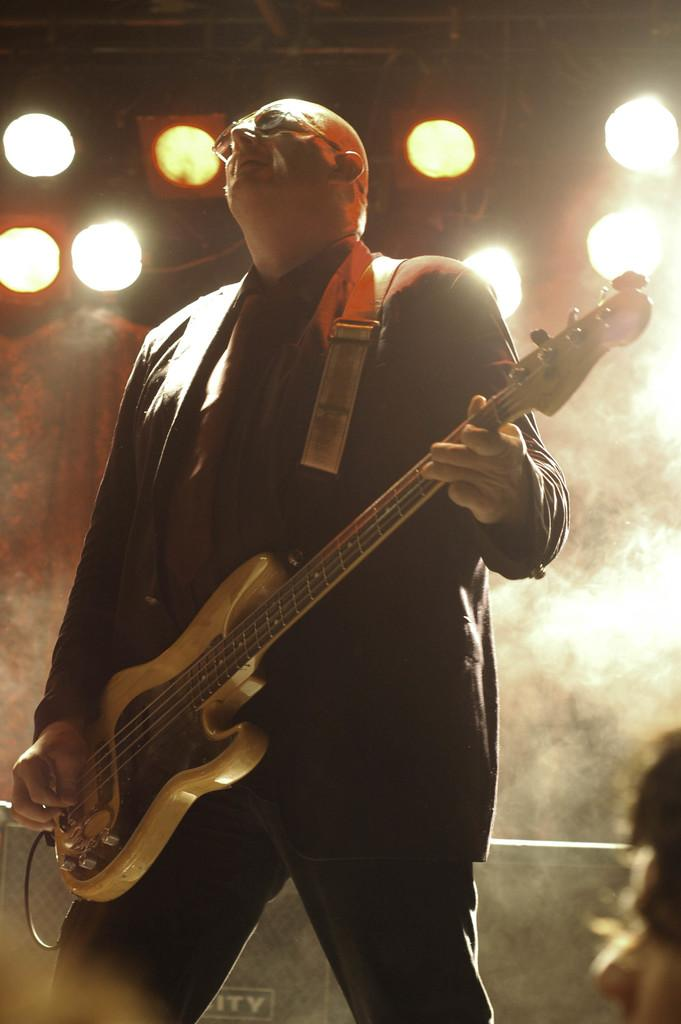What is the man in the image doing? The man is playing a guitar. Can you describe the background of the image? There are dogs and lights in the background of the image. What type of substance is the man using to play the guitar in the image? There is no substance mentioned or visible in the image; the man is simply playing the guitar with his hands. 